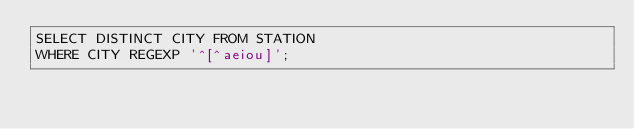<code> <loc_0><loc_0><loc_500><loc_500><_SQL_>SELECT DISTINCT CITY FROM STATION
WHERE CITY REGEXP '^[^aeiou]';</code> 